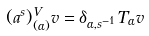Convert formula to latex. <formula><loc_0><loc_0><loc_500><loc_500>( a ^ { s } ) ^ { V } _ { ( \alpha ) } v = \delta _ { \alpha , s ^ { - 1 } } T _ { \alpha } v</formula> 